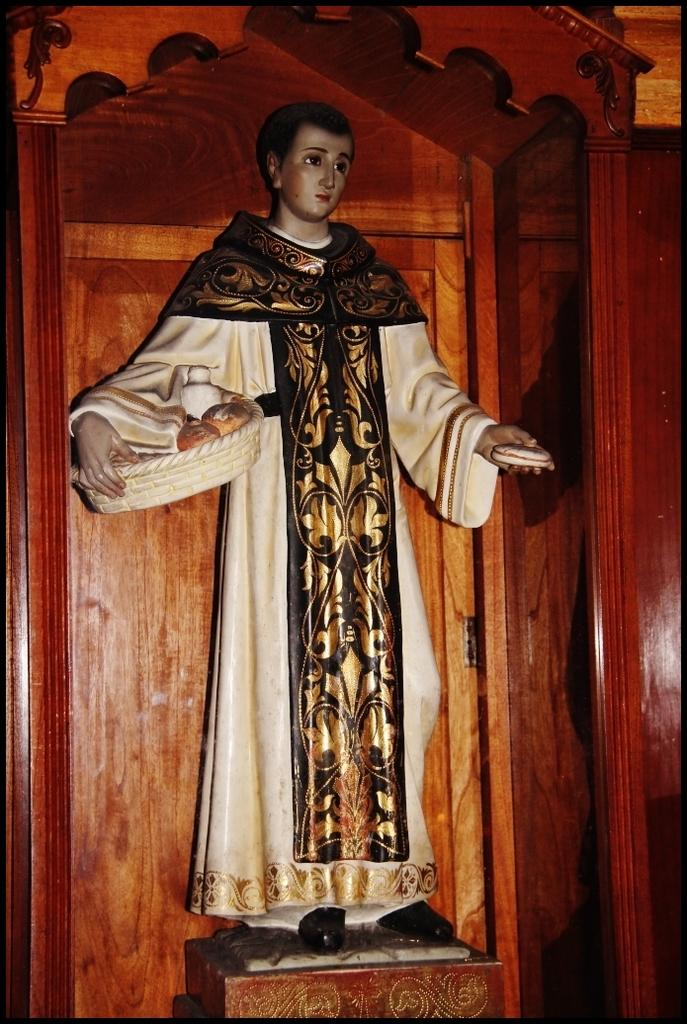What is the main subject of the image? There is a statue of a person in the image. What is the person in the statue wearing? The person is wearing a white dress. What is the person holding in their hands? The person is holding an object in their hands. What material is the background of the image made of? The background of the image is made of wood. How many giraffes can be seen in the image? There are no giraffes present in the image; it features a statue of a person. What type of bulb is used to illuminate the statue in the image? There is no information about any bulbs or lighting in the image; it only shows a statue of a person with a white dress and an object in their hands, standing in front of a wooden background. 